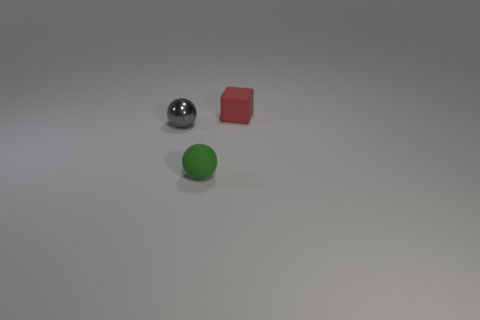Add 1 small cyan cylinders. How many objects exist? 4 Subtract 1 spheres. How many spheres are left? 1 Subtract all metallic spheres. Subtract all tiny red rubber blocks. How many objects are left? 1 Add 2 red cubes. How many red cubes are left? 3 Add 2 tiny green matte spheres. How many tiny green matte spheres exist? 3 Subtract 0 yellow cylinders. How many objects are left? 3 Subtract all spheres. How many objects are left? 1 Subtract all yellow balls. Subtract all gray cylinders. How many balls are left? 2 